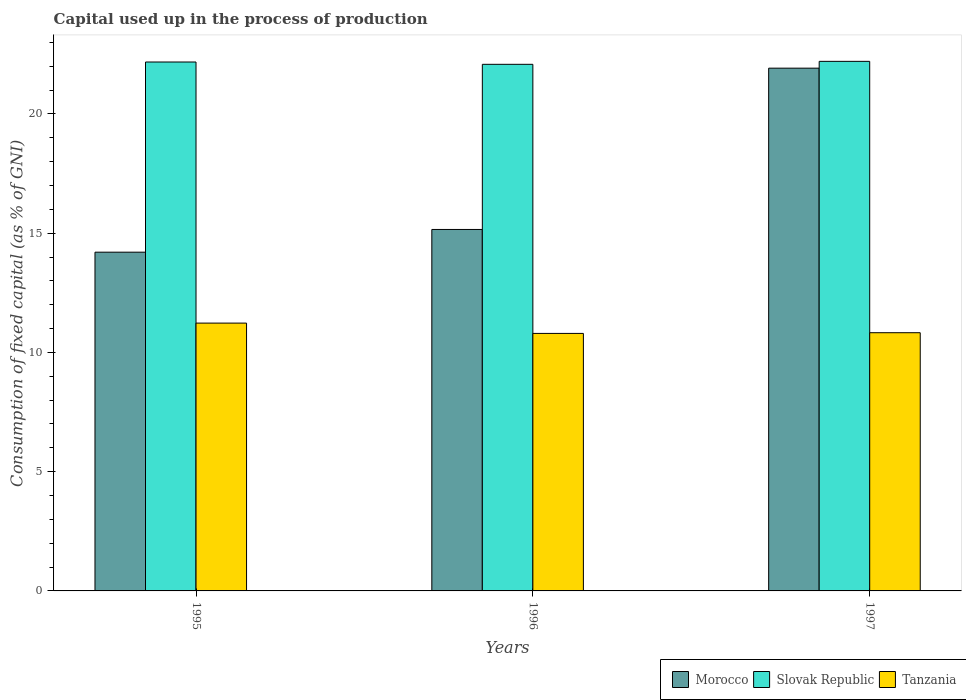How many groups of bars are there?
Provide a succinct answer. 3. What is the label of the 1st group of bars from the left?
Offer a terse response. 1995. What is the capital used up in the process of production in Slovak Republic in 1996?
Offer a very short reply. 22.08. Across all years, what is the maximum capital used up in the process of production in Slovak Republic?
Your answer should be compact. 22.21. Across all years, what is the minimum capital used up in the process of production in Morocco?
Ensure brevity in your answer.  14.2. In which year was the capital used up in the process of production in Tanzania minimum?
Your answer should be very brief. 1996. What is the total capital used up in the process of production in Morocco in the graph?
Provide a succinct answer. 51.28. What is the difference between the capital used up in the process of production in Tanzania in 1995 and that in 1997?
Ensure brevity in your answer.  0.4. What is the difference between the capital used up in the process of production in Slovak Republic in 1997 and the capital used up in the process of production in Tanzania in 1996?
Provide a succinct answer. 11.41. What is the average capital used up in the process of production in Morocco per year?
Give a very brief answer. 17.09. In the year 1995, what is the difference between the capital used up in the process of production in Slovak Republic and capital used up in the process of production in Tanzania?
Keep it short and to the point. 10.95. In how many years, is the capital used up in the process of production in Morocco greater than 10 %?
Make the answer very short. 3. What is the ratio of the capital used up in the process of production in Slovak Republic in 1996 to that in 1997?
Your response must be concise. 0.99. What is the difference between the highest and the second highest capital used up in the process of production in Slovak Republic?
Your response must be concise. 0.03. What is the difference between the highest and the lowest capital used up in the process of production in Tanzania?
Offer a very short reply. 0.43. What does the 1st bar from the left in 1995 represents?
Your answer should be compact. Morocco. What does the 2nd bar from the right in 1995 represents?
Make the answer very short. Slovak Republic. Are all the bars in the graph horizontal?
Offer a very short reply. No. How many years are there in the graph?
Your answer should be compact. 3. Where does the legend appear in the graph?
Offer a terse response. Bottom right. How are the legend labels stacked?
Your answer should be very brief. Horizontal. What is the title of the graph?
Provide a short and direct response. Capital used up in the process of production. Does "Morocco" appear as one of the legend labels in the graph?
Offer a terse response. Yes. What is the label or title of the Y-axis?
Ensure brevity in your answer.  Consumption of fixed capital (as % of GNI). What is the Consumption of fixed capital (as % of GNI) of Morocco in 1995?
Provide a succinct answer. 14.2. What is the Consumption of fixed capital (as % of GNI) in Slovak Republic in 1995?
Your answer should be compact. 22.18. What is the Consumption of fixed capital (as % of GNI) of Tanzania in 1995?
Ensure brevity in your answer.  11.23. What is the Consumption of fixed capital (as % of GNI) of Morocco in 1996?
Your answer should be compact. 15.16. What is the Consumption of fixed capital (as % of GNI) of Slovak Republic in 1996?
Provide a short and direct response. 22.08. What is the Consumption of fixed capital (as % of GNI) in Tanzania in 1996?
Keep it short and to the point. 10.8. What is the Consumption of fixed capital (as % of GNI) in Morocco in 1997?
Your answer should be compact. 21.92. What is the Consumption of fixed capital (as % of GNI) of Slovak Republic in 1997?
Make the answer very short. 22.21. What is the Consumption of fixed capital (as % of GNI) of Tanzania in 1997?
Provide a succinct answer. 10.83. Across all years, what is the maximum Consumption of fixed capital (as % of GNI) of Morocco?
Keep it short and to the point. 21.92. Across all years, what is the maximum Consumption of fixed capital (as % of GNI) in Slovak Republic?
Your answer should be compact. 22.21. Across all years, what is the maximum Consumption of fixed capital (as % of GNI) in Tanzania?
Your answer should be compact. 11.23. Across all years, what is the minimum Consumption of fixed capital (as % of GNI) in Morocco?
Provide a short and direct response. 14.2. Across all years, what is the minimum Consumption of fixed capital (as % of GNI) in Slovak Republic?
Your answer should be very brief. 22.08. Across all years, what is the minimum Consumption of fixed capital (as % of GNI) in Tanzania?
Keep it short and to the point. 10.8. What is the total Consumption of fixed capital (as % of GNI) in Morocco in the graph?
Provide a succinct answer. 51.28. What is the total Consumption of fixed capital (as % of GNI) of Slovak Republic in the graph?
Provide a short and direct response. 66.46. What is the total Consumption of fixed capital (as % of GNI) in Tanzania in the graph?
Make the answer very short. 32.85. What is the difference between the Consumption of fixed capital (as % of GNI) of Morocco in 1995 and that in 1996?
Your response must be concise. -0.95. What is the difference between the Consumption of fixed capital (as % of GNI) in Slovak Republic in 1995 and that in 1996?
Offer a terse response. 0.1. What is the difference between the Consumption of fixed capital (as % of GNI) of Tanzania in 1995 and that in 1996?
Offer a very short reply. 0.43. What is the difference between the Consumption of fixed capital (as % of GNI) of Morocco in 1995 and that in 1997?
Your response must be concise. -7.72. What is the difference between the Consumption of fixed capital (as % of GNI) in Slovak Republic in 1995 and that in 1997?
Offer a terse response. -0.03. What is the difference between the Consumption of fixed capital (as % of GNI) in Tanzania in 1995 and that in 1997?
Your response must be concise. 0.4. What is the difference between the Consumption of fixed capital (as % of GNI) of Morocco in 1996 and that in 1997?
Make the answer very short. -6.76. What is the difference between the Consumption of fixed capital (as % of GNI) in Slovak Republic in 1996 and that in 1997?
Provide a short and direct response. -0.12. What is the difference between the Consumption of fixed capital (as % of GNI) of Tanzania in 1996 and that in 1997?
Ensure brevity in your answer.  -0.03. What is the difference between the Consumption of fixed capital (as % of GNI) of Morocco in 1995 and the Consumption of fixed capital (as % of GNI) of Slovak Republic in 1996?
Provide a succinct answer. -7.88. What is the difference between the Consumption of fixed capital (as % of GNI) of Morocco in 1995 and the Consumption of fixed capital (as % of GNI) of Tanzania in 1996?
Provide a succinct answer. 3.41. What is the difference between the Consumption of fixed capital (as % of GNI) of Slovak Republic in 1995 and the Consumption of fixed capital (as % of GNI) of Tanzania in 1996?
Provide a short and direct response. 11.38. What is the difference between the Consumption of fixed capital (as % of GNI) in Morocco in 1995 and the Consumption of fixed capital (as % of GNI) in Slovak Republic in 1997?
Keep it short and to the point. -8. What is the difference between the Consumption of fixed capital (as % of GNI) in Morocco in 1995 and the Consumption of fixed capital (as % of GNI) in Tanzania in 1997?
Offer a very short reply. 3.38. What is the difference between the Consumption of fixed capital (as % of GNI) of Slovak Republic in 1995 and the Consumption of fixed capital (as % of GNI) of Tanzania in 1997?
Ensure brevity in your answer.  11.35. What is the difference between the Consumption of fixed capital (as % of GNI) in Morocco in 1996 and the Consumption of fixed capital (as % of GNI) in Slovak Republic in 1997?
Give a very brief answer. -7.05. What is the difference between the Consumption of fixed capital (as % of GNI) of Morocco in 1996 and the Consumption of fixed capital (as % of GNI) of Tanzania in 1997?
Provide a short and direct response. 4.33. What is the difference between the Consumption of fixed capital (as % of GNI) of Slovak Republic in 1996 and the Consumption of fixed capital (as % of GNI) of Tanzania in 1997?
Make the answer very short. 11.25. What is the average Consumption of fixed capital (as % of GNI) in Morocco per year?
Ensure brevity in your answer.  17.09. What is the average Consumption of fixed capital (as % of GNI) in Slovak Republic per year?
Your response must be concise. 22.15. What is the average Consumption of fixed capital (as % of GNI) in Tanzania per year?
Your answer should be very brief. 10.95. In the year 1995, what is the difference between the Consumption of fixed capital (as % of GNI) in Morocco and Consumption of fixed capital (as % of GNI) in Slovak Republic?
Keep it short and to the point. -7.97. In the year 1995, what is the difference between the Consumption of fixed capital (as % of GNI) in Morocco and Consumption of fixed capital (as % of GNI) in Tanzania?
Offer a terse response. 2.97. In the year 1995, what is the difference between the Consumption of fixed capital (as % of GNI) of Slovak Republic and Consumption of fixed capital (as % of GNI) of Tanzania?
Your answer should be compact. 10.95. In the year 1996, what is the difference between the Consumption of fixed capital (as % of GNI) of Morocco and Consumption of fixed capital (as % of GNI) of Slovak Republic?
Your answer should be compact. -6.92. In the year 1996, what is the difference between the Consumption of fixed capital (as % of GNI) in Morocco and Consumption of fixed capital (as % of GNI) in Tanzania?
Your answer should be very brief. 4.36. In the year 1996, what is the difference between the Consumption of fixed capital (as % of GNI) in Slovak Republic and Consumption of fixed capital (as % of GNI) in Tanzania?
Give a very brief answer. 11.28. In the year 1997, what is the difference between the Consumption of fixed capital (as % of GNI) of Morocco and Consumption of fixed capital (as % of GNI) of Slovak Republic?
Offer a terse response. -0.29. In the year 1997, what is the difference between the Consumption of fixed capital (as % of GNI) of Morocco and Consumption of fixed capital (as % of GNI) of Tanzania?
Ensure brevity in your answer.  11.09. In the year 1997, what is the difference between the Consumption of fixed capital (as % of GNI) in Slovak Republic and Consumption of fixed capital (as % of GNI) in Tanzania?
Ensure brevity in your answer.  11.38. What is the ratio of the Consumption of fixed capital (as % of GNI) in Morocco in 1995 to that in 1996?
Make the answer very short. 0.94. What is the ratio of the Consumption of fixed capital (as % of GNI) of Slovak Republic in 1995 to that in 1996?
Give a very brief answer. 1. What is the ratio of the Consumption of fixed capital (as % of GNI) of Tanzania in 1995 to that in 1996?
Offer a terse response. 1.04. What is the ratio of the Consumption of fixed capital (as % of GNI) of Morocco in 1995 to that in 1997?
Provide a short and direct response. 0.65. What is the ratio of the Consumption of fixed capital (as % of GNI) of Slovak Republic in 1995 to that in 1997?
Give a very brief answer. 1. What is the ratio of the Consumption of fixed capital (as % of GNI) in Tanzania in 1995 to that in 1997?
Ensure brevity in your answer.  1.04. What is the ratio of the Consumption of fixed capital (as % of GNI) of Morocco in 1996 to that in 1997?
Give a very brief answer. 0.69. What is the ratio of the Consumption of fixed capital (as % of GNI) in Tanzania in 1996 to that in 1997?
Give a very brief answer. 1. What is the difference between the highest and the second highest Consumption of fixed capital (as % of GNI) in Morocco?
Ensure brevity in your answer.  6.76. What is the difference between the highest and the second highest Consumption of fixed capital (as % of GNI) of Slovak Republic?
Offer a very short reply. 0.03. What is the difference between the highest and the second highest Consumption of fixed capital (as % of GNI) of Tanzania?
Give a very brief answer. 0.4. What is the difference between the highest and the lowest Consumption of fixed capital (as % of GNI) in Morocco?
Give a very brief answer. 7.72. What is the difference between the highest and the lowest Consumption of fixed capital (as % of GNI) of Slovak Republic?
Keep it short and to the point. 0.12. What is the difference between the highest and the lowest Consumption of fixed capital (as % of GNI) in Tanzania?
Ensure brevity in your answer.  0.43. 